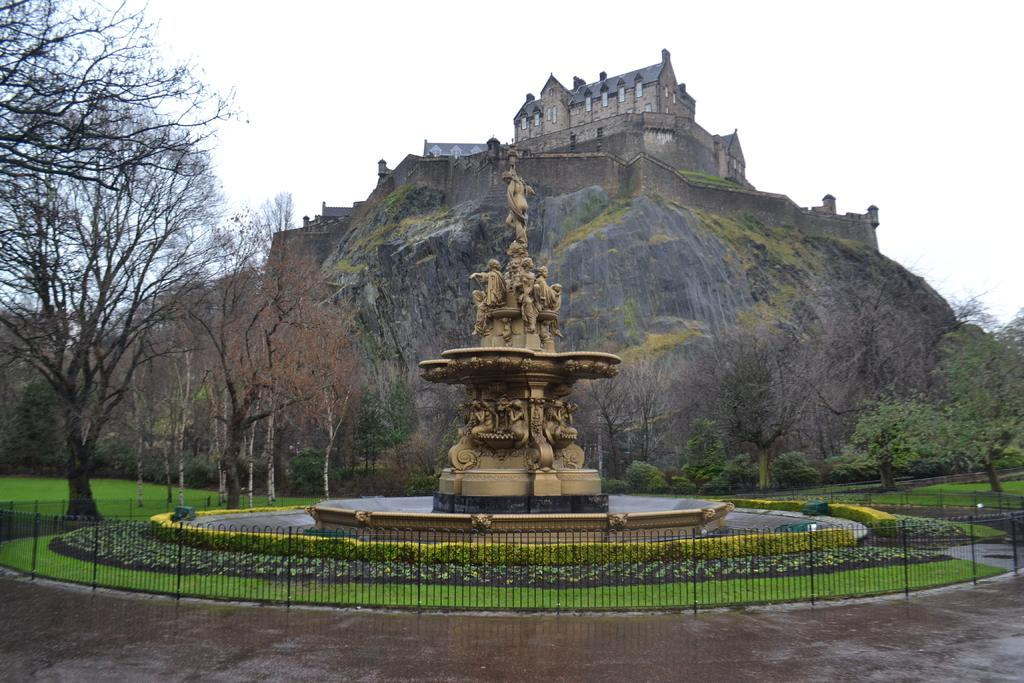What is the main subject in the image? There is a statue in the image. What type of natural elements can be seen in the image? There are trees, plants, grass, and a mountain in the image. What type of man-made structures are present in the image? There is a fence and a building on the mountain in the image. What is visible in the background of the image? The sky is visible in the background of the image. What type of sheet is covering the mountain in the image? There is no sheet covering the mountain in the image; it is a natural formation. 